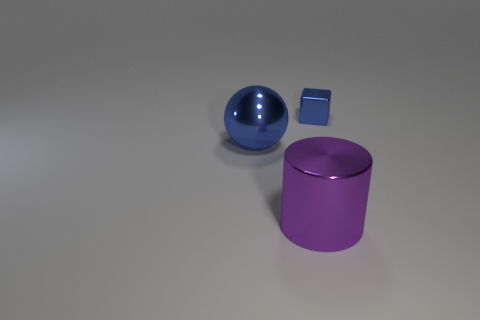Add 1 large objects. How many objects exist? 4 Subtract all balls. How many objects are left? 2 Subtract all green cylinders. Subtract all blue spheres. How many cylinders are left? 1 Subtract all big spheres. Subtract all metal cubes. How many objects are left? 1 Add 3 large balls. How many large balls are left? 4 Add 1 large blue rubber objects. How many large blue rubber objects exist? 1 Subtract 0 brown spheres. How many objects are left? 3 